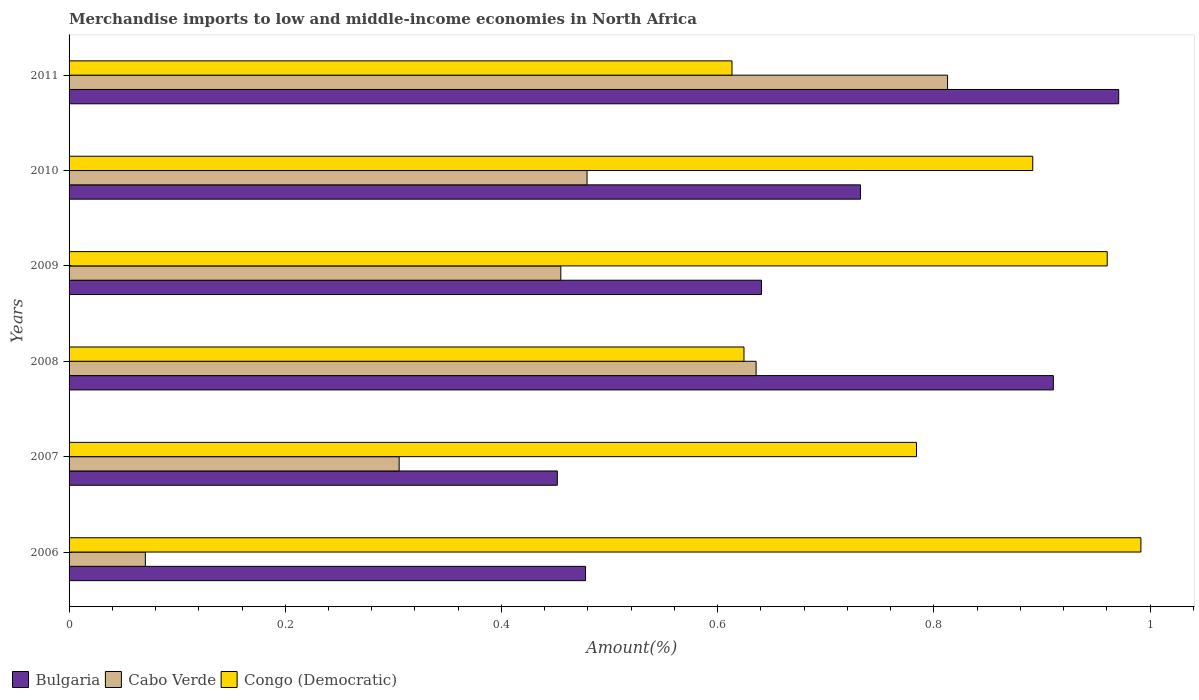How many groups of bars are there?
Provide a short and direct response. 6. How many bars are there on the 5th tick from the top?
Give a very brief answer. 3. How many bars are there on the 3rd tick from the bottom?
Provide a succinct answer. 3. In how many cases, is the number of bars for a given year not equal to the number of legend labels?
Make the answer very short. 0. What is the percentage of amount earned from merchandise imports in Bulgaria in 2008?
Keep it short and to the point. 0.91. Across all years, what is the maximum percentage of amount earned from merchandise imports in Bulgaria?
Provide a succinct answer. 0.97. Across all years, what is the minimum percentage of amount earned from merchandise imports in Bulgaria?
Provide a short and direct response. 0.45. In which year was the percentage of amount earned from merchandise imports in Bulgaria minimum?
Provide a succinct answer. 2007. What is the total percentage of amount earned from merchandise imports in Bulgaria in the graph?
Keep it short and to the point. 4.18. What is the difference between the percentage of amount earned from merchandise imports in Bulgaria in 2009 and that in 2011?
Provide a succinct answer. -0.33. What is the difference between the percentage of amount earned from merchandise imports in Cabo Verde in 2010 and the percentage of amount earned from merchandise imports in Congo (Democratic) in 2006?
Keep it short and to the point. -0.51. What is the average percentage of amount earned from merchandise imports in Congo (Democratic) per year?
Offer a very short reply. 0.81. In the year 2010, what is the difference between the percentage of amount earned from merchandise imports in Bulgaria and percentage of amount earned from merchandise imports in Congo (Democratic)?
Offer a very short reply. -0.16. In how many years, is the percentage of amount earned from merchandise imports in Congo (Democratic) greater than 0.36 %?
Offer a terse response. 6. What is the ratio of the percentage of amount earned from merchandise imports in Cabo Verde in 2006 to that in 2008?
Your answer should be very brief. 0.11. Is the percentage of amount earned from merchandise imports in Bulgaria in 2007 less than that in 2008?
Your response must be concise. Yes. What is the difference between the highest and the second highest percentage of amount earned from merchandise imports in Bulgaria?
Keep it short and to the point. 0.06. What is the difference between the highest and the lowest percentage of amount earned from merchandise imports in Cabo Verde?
Your answer should be compact. 0.74. What does the 1st bar from the top in 2011 represents?
Provide a short and direct response. Congo (Democratic). What does the 3rd bar from the bottom in 2010 represents?
Your answer should be compact. Congo (Democratic). How many bars are there?
Make the answer very short. 18. Does the graph contain any zero values?
Keep it short and to the point. No. Does the graph contain grids?
Your response must be concise. No. Where does the legend appear in the graph?
Your answer should be compact. Bottom left. How are the legend labels stacked?
Your answer should be very brief. Horizontal. What is the title of the graph?
Keep it short and to the point. Merchandise imports to low and middle-income economies in North Africa. Does "Arab World" appear as one of the legend labels in the graph?
Provide a succinct answer. No. What is the label or title of the X-axis?
Provide a succinct answer. Amount(%). What is the label or title of the Y-axis?
Your answer should be very brief. Years. What is the Amount(%) in Bulgaria in 2006?
Your answer should be compact. 0.48. What is the Amount(%) of Cabo Verde in 2006?
Give a very brief answer. 0.07. What is the Amount(%) of Congo (Democratic) in 2006?
Keep it short and to the point. 0.99. What is the Amount(%) in Bulgaria in 2007?
Your response must be concise. 0.45. What is the Amount(%) of Cabo Verde in 2007?
Provide a short and direct response. 0.31. What is the Amount(%) of Congo (Democratic) in 2007?
Your answer should be compact. 0.78. What is the Amount(%) in Bulgaria in 2008?
Ensure brevity in your answer.  0.91. What is the Amount(%) of Cabo Verde in 2008?
Your answer should be compact. 0.64. What is the Amount(%) in Congo (Democratic) in 2008?
Offer a terse response. 0.62. What is the Amount(%) of Bulgaria in 2009?
Provide a short and direct response. 0.64. What is the Amount(%) of Cabo Verde in 2009?
Your answer should be compact. 0.45. What is the Amount(%) of Congo (Democratic) in 2009?
Keep it short and to the point. 0.96. What is the Amount(%) of Bulgaria in 2010?
Keep it short and to the point. 0.73. What is the Amount(%) in Cabo Verde in 2010?
Offer a very short reply. 0.48. What is the Amount(%) of Congo (Democratic) in 2010?
Provide a short and direct response. 0.89. What is the Amount(%) in Bulgaria in 2011?
Provide a succinct answer. 0.97. What is the Amount(%) in Cabo Verde in 2011?
Your response must be concise. 0.81. What is the Amount(%) in Congo (Democratic) in 2011?
Your answer should be very brief. 0.61. Across all years, what is the maximum Amount(%) of Bulgaria?
Provide a short and direct response. 0.97. Across all years, what is the maximum Amount(%) of Cabo Verde?
Provide a succinct answer. 0.81. Across all years, what is the maximum Amount(%) of Congo (Democratic)?
Provide a succinct answer. 0.99. Across all years, what is the minimum Amount(%) in Bulgaria?
Offer a very short reply. 0.45. Across all years, what is the minimum Amount(%) of Cabo Verde?
Ensure brevity in your answer.  0.07. Across all years, what is the minimum Amount(%) in Congo (Democratic)?
Provide a succinct answer. 0.61. What is the total Amount(%) in Bulgaria in the graph?
Provide a short and direct response. 4.18. What is the total Amount(%) in Cabo Verde in the graph?
Your answer should be compact. 2.76. What is the total Amount(%) in Congo (Democratic) in the graph?
Ensure brevity in your answer.  4.87. What is the difference between the Amount(%) in Bulgaria in 2006 and that in 2007?
Your response must be concise. 0.03. What is the difference between the Amount(%) in Cabo Verde in 2006 and that in 2007?
Provide a succinct answer. -0.23. What is the difference between the Amount(%) in Congo (Democratic) in 2006 and that in 2007?
Provide a succinct answer. 0.21. What is the difference between the Amount(%) in Bulgaria in 2006 and that in 2008?
Provide a short and direct response. -0.43. What is the difference between the Amount(%) of Cabo Verde in 2006 and that in 2008?
Provide a short and direct response. -0.56. What is the difference between the Amount(%) in Congo (Democratic) in 2006 and that in 2008?
Ensure brevity in your answer.  0.37. What is the difference between the Amount(%) in Bulgaria in 2006 and that in 2009?
Make the answer very short. -0.16. What is the difference between the Amount(%) in Cabo Verde in 2006 and that in 2009?
Make the answer very short. -0.38. What is the difference between the Amount(%) in Congo (Democratic) in 2006 and that in 2009?
Your answer should be very brief. 0.03. What is the difference between the Amount(%) in Bulgaria in 2006 and that in 2010?
Provide a short and direct response. -0.25. What is the difference between the Amount(%) of Cabo Verde in 2006 and that in 2010?
Your answer should be very brief. -0.41. What is the difference between the Amount(%) of Congo (Democratic) in 2006 and that in 2010?
Offer a very short reply. 0.1. What is the difference between the Amount(%) of Bulgaria in 2006 and that in 2011?
Your answer should be compact. -0.49. What is the difference between the Amount(%) in Cabo Verde in 2006 and that in 2011?
Give a very brief answer. -0.74. What is the difference between the Amount(%) in Congo (Democratic) in 2006 and that in 2011?
Your answer should be compact. 0.38. What is the difference between the Amount(%) in Bulgaria in 2007 and that in 2008?
Offer a terse response. -0.46. What is the difference between the Amount(%) of Cabo Verde in 2007 and that in 2008?
Your answer should be very brief. -0.33. What is the difference between the Amount(%) of Congo (Democratic) in 2007 and that in 2008?
Make the answer very short. 0.16. What is the difference between the Amount(%) in Bulgaria in 2007 and that in 2009?
Your answer should be very brief. -0.19. What is the difference between the Amount(%) in Cabo Verde in 2007 and that in 2009?
Ensure brevity in your answer.  -0.15. What is the difference between the Amount(%) of Congo (Democratic) in 2007 and that in 2009?
Provide a short and direct response. -0.18. What is the difference between the Amount(%) of Bulgaria in 2007 and that in 2010?
Offer a very short reply. -0.28. What is the difference between the Amount(%) in Cabo Verde in 2007 and that in 2010?
Ensure brevity in your answer.  -0.17. What is the difference between the Amount(%) in Congo (Democratic) in 2007 and that in 2010?
Make the answer very short. -0.11. What is the difference between the Amount(%) in Bulgaria in 2007 and that in 2011?
Your answer should be compact. -0.52. What is the difference between the Amount(%) in Cabo Verde in 2007 and that in 2011?
Your answer should be very brief. -0.51. What is the difference between the Amount(%) in Congo (Democratic) in 2007 and that in 2011?
Ensure brevity in your answer.  0.17. What is the difference between the Amount(%) of Bulgaria in 2008 and that in 2009?
Provide a short and direct response. 0.27. What is the difference between the Amount(%) of Cabo Verde in 2008 and that in 2009?
Ensure brevity in your answer.  0.18. What is the difference between the Amount(%) of Congo (Democratic) in 2008 and that in 2009?
Your answer should be very brief. -0.34. What is the difference between the Amount(%) in Bulgaria in 2008 and that in 2010?
Keep it short and to the point. 0.18. What is the difference between the Amount(%) in Cabo Verde in 2008 and that in 2010?
Provide a succinct answer. 0.16. What is the difference between the Amount(%) in Congo (Democratic) in 2008 and that in 2010?
Your response must be concise. -0.27. What is the difference between the Amount(%) of Bulgaria in 2008 and that in 2011?
Make the answer very short. -0.06. What is the difference between the Amount(%) of Cabo Verde in 2008 and that in 2011?
Provide a succinct answer. -0.18. What is the difference between the Amount(%) in Congo (Democratic) in 2008 and that in 2011?
Your response must be concise. 0.01. What is the difference between the Amount(%) of Bulgaria in 2009 and that in 2010?
Your response must be concise. -0.09. What is the difference between the Amount(%) in Cabo Verde in 2009 and that in 2010?
Offer a terse response. -0.02. What is the difference between the Amount(%) in Congo (Democratic) in 2009 and that in 2010?
Make the answer very short. 0.07. What is the difference between the Amount(%) of Bulgaria in 2009 and that in 2011?
Ensure brevity in your answer.  -0.33. What is the difference between the Amount(%) in Cabo Verde in 2009 and that in 2011?
Make the answer very short. -0.36. What is the difference between the Amount(%) of Congo (Democratic) in 2009 and that in 2011?
Keep it short and to the point. 0.35. What is the difference between the Amount(%) of Bulgaria in 2010 and that in 2011?
Give a very brief answer. -0.24. What is the difference between the Amount(%) in Cabo Verde in 2010 and that in 2011?
Make the answer very short. -0.33. What is the difference between the Amount(%) of Congo (Democratic) in 2010 and that in 2011?
Keep it short and to the point. 0.28. What is the difference between the Amount(%) of Bulgaria in 2006 and the Amount(%) of Cabo Verde in 2007?
Make the answer very short. 0.17. What is the difference between the Amount(%) of Bulgaria in 2006 and the Amount(%) of Congo (Democratic) in 2007?
Ensure brevity in your answer.  -0.31. What is the difference between the Amount(%) in Cabo Verde in 2006 and the Amount(%) in Congo (Democratic) in 2007?
Your response must be concise. -0.71. What is the difference between the Amount(%) in Bulgaria in 2006 and the Amount(%) in Cabo Verde in 2008?
Provide a short and direct response. -0.16. What is the difference between the Amount(%) of Bulgaria in 2006 and the Amount(%) of Congo (Democratic) in 2008?
Your answer should be compact. -0.15. What is the difference between the Amount(%) in Cabo Verde in 2006 and the Amount(%) in Congo (Democratic) in 2008?
Provide a short and direct response. -0.55. What is the difference between the Amount(%) in Bulgaria in 2006 and the Amount(%) in Cabo Verde in 2009?
Offer a very short reply. 0.02. What is the difference between the Amount(%) of Bulgaria in 2006 and the Amount(%) of Congo (Democratic) in 2009?
Make the answer very short. -0.48. What is the difference between the Amount(%) of Cabo Verde in 2006 and the Amount(%) of Congo (Democratic) in 2009?
Your response must be concise. -0.89. What is the difference between the Amount(%) in Bulgaria in 2006 and the Amount(%) in Cabo Verde in 2010?
Your answer should be compact. -0. What is the difference between the Amount(%) of Bulgaria in 2006 and the Amount(%) of Congo (Democratic) in 2010?
Offer a terse response. -0.41. What is the difference between the Amount(%) of Cabo Verde in 2006 and the Amount(%) of Congo (Democratic) in 2010?
Your answer should be very brief. -0.82. What is the difference between the Amount(%) in Bulgaria in 2006 and the Amount(%) in Cabo Verde in 2011?
Keep it short and to the point. -0.33. What is the difference between the Amount(%) in Bulgaria in 2006 and the Amount(%) in Congo (Democratic) in 2011?
Keep it short and to the point. -0.14. What is the difference between the Amount(%) in Cabo Verde in 2006 and the Amount(%) in Congo (Democratic) in 2011?
Make the answer very short. -0.54. What is the difference between the Amount(%) in Bulgaria in 2007 and the Amount(%) in Cabo Verde in 2008?
Your answer should be very brief. -0.18. What is the difference between the Amount(%) in Bulgaria in 2007 and the Amount(%) in Congo (Democratic) in 2008?
Make the answer very short. -0.17. What is the difference between the Amount(%) of Cabo Verde in 2007 and the Amount(%) of Congo (Democratic) in 2008?
Your answer should be compact. -0.32. What is the difference between the Amount(%) of Bulgaria in 2007 and the Amount(%) of Cabo Verde in 2009?
Ensure brevity in your answer.  -0. What is the difference between the Amount(%) of Bulgaria in 2007 and the Amount(%) of Congo (Democratic) in 2009?
Your answer should be compact. -0.51. What is the difference between the Amount(%) of Cabo Verde in 2007 and the Amount(%) of Congo (Democratic) in 2009?
Provide a succinct answer. -0.66. What is the difference between the Amount(%) of Bulgaria in 2007 and the Amount(%) of Cabo Verde in 2010?
Keep it short and to the point. -0.03. What is the difference between the Amount(%) of Bulgaria in 2007 and the Amount(%) of Congo (Democratic) in 2010?
Your answer should be compact. -0.44. What is the difference between the Amount(%) of Cabo Verde in 2007 and the Amount(%) of Congo (Democratic) in 2010?
Offer a terse response. -0.59. What is the difference between the Amount(%) of Bulgaria in 2007 and the Amount(%) of Cabo Verde in 2011?
Provide a short and direct response. -0.36. What is the difference between the Amount(%) in Bulgaria in 2007 and the Amount(%) in Congo (Democratic) in 2011?
Your answer should be compact. -0.16. What is the difference between the Amount(%) of Cabo Verde in 2007 and the Amount(%) of Congo (Democratic) in 2011?
Provide a succinct answer. -0.31. What is the difference between the Amount(%) of Bulgaria in 2008 and the Amount(%) of Cabo Verde in 2009?
Offer a terse response. 0.46. What is the difference between the Amount(%) in Bulgaria in 2008 and the Amount(%) in Congo (Democratic) in 2009?
Give a very brief answer. -0.05. What is the difference between the Amount(%) of Cabo Verde in 2008 and the Amount(%) of Congo (Democratic) in 2009?
Your answer should be very brief. -0.32. What is the difference between the Amount(%) of Bulgaria in 2008 and the Amount(%) of Cabo Verde in 2010?
Offer a very short reply. 0.43. What is the difference between the Amount(%) in Bulgaria in 2008 and the Amount(%) in Congo (Democratic) in 2010?
Your answer should be compact. 0.02. What is the difference between the Amount(%) of Cabo Verde in 2008 and the Amount(%) of Congo (Democratic) in 2010?
Make the answer very short. -0.26. What is the difference between the Amount(%) of Bulgaria in 2008 and the Amount(%) of Cabo Verde in 2011?
Your response must be concise. 0.1. What is the difference between the Amount(%) of Bulgaria in 2008 and the Amount(%) of Congo (Democratic) in 2011?
Offer a terse response. 0.3. What is the difference between the Amount(%) in Cabo Verde in 2008 and the Amount(%) in Congo (Democratic) in 2011?
Offer a very short reply. 0.02. What is the difference between the Amount(%) in Bulgaria in 2009 and the Amount(%) in Cabo Verde in 2010?
Offer a terse response. 0.16. What is the difference between the Amount(%) in Bulgaria in 2009 and the Amount(%) in Congo (Democratic) in 2010?
Give a very brief answer. -0.25. What is the difference between the Amount(%) in Cabo Verde in 2009 and the Amount(%) in Congo (Democratic) in 2010?
Offer a very short reply. -0.44. What is the difference between the Amount(%) in Bulgaria in 2009 and the Amount(%) in Cabo Verde in 2011?
Your answer should be compact. -0.17. What is the difference between the Amount(%) in Bulgaria in 2009 and the Amount(%) in Congo (Democratic) in 2011?
Make the answer very short. 0.03. What is the difference between the Amount(%) in Cabo Verde in 2009 and the Amount(%) in Congo (Democratic) in 2011?
Provide a short and direct response. -0.16. What is the difference between the Amount(%) in Bulgaria in 2010 and the Amount(%) in Cabo Verde in 2011?
Keep it short and to the point. -0.08. What is the difference between the Amount(%) in Bulgaria in 2010 and the Amount(%) in Congo (Democratic) in 2011?
Ensure brevity in your answer.  0.12. What is the difference between the Amount(%) of Cabo Verde in 2010 and the Amount(%) of Congo (Democratic) in 2011?
Provide a short and direct response. -0.13. What is the average Amount(%) of Bulgaria per year?
Make the answer very short. 0.7. What is the average Amount(%) of Cabo Verde per year?
Ensure brevity in your answer.  0.46. What is the average Amount(%) of Congo (Democratic) per year?
Offer a terse response. 0.81. In the year 2006, what is the difference between the Amount(%) of Bulgaria and Amount(%) of Cabo Verde?
Offer a very short reply. 0.41. In the year 2006, what is the difference between the Amount(%) in Bulgaria and Amount(%) in Congo (Democratic)?
Your answer should be compact. -0.51. In the year 2006, what is the difference between the Amount(%) of Cabo Verde and Amount(%) of Congo (Democratic)?
Provide a succinct answer. -0.92. In the year 2007, what is the difference between the Amount(%) in Bulgaria and Amount(%) in Cabo Verde?
Provide a succinct answer. 0.15. In the year 2007, what is the difference between the Amount(%) in Bulgaria and Amount(%) in Congo (Democratic)?
Make the answer very short. -0.33. In the year 2007, what is the difference between the Amount(%) in Cabo Verde and Amount(%) in Congo (Democratic)?
Make the answer very short. -0.48. In the year 2008, what is the difference between the Amount(%) in Bulgaria and Amount(%) in Cabo Verde?
Give a very brief answer. 0.28. In the year 2008, what is the difference between the Amount(%) in Bulgaria and Amount(%) in Congo (Democratic)?
Ensure brevity in your answer.  0.29. In the year 2008, what is the difference between the Amount(%) of Cabo Verde and Amount(%) of Congo (Democratic)?
Offer a very short reply. 0.01. In the year 2009, what is the difference between the Amount(%) in Bulgaria and Amount(%) in Cabo Verde?
Your answer should be compact. 0.19. In the year 2009, what is the difference between the Amount(%) in Bulgaria and Amount(%) in Congo (Democratic)?
Offer a terse response. -0.32. In the year 2009, what is the difference between the Amount(%) of Cabo Verde and Amount(%) of Congo (Democratic)?
Offer a very short reply. -0.51. In the year 2010, what is the difference between the Amount(%) of Bulgaria and Amount(%) of Cabo Verde?
Your answer should be compact. 0.25. In the year 2010, what is the difference between the Amount(%) of Bulgaria and Amount(%) of Congo (Democratic)?
Provide a short and direct response. -0.16. In the year 2010, what is the difference between the Amount(%) in Cabo Verde and Amount(%) in Congo (Democratic)?
Keep it short and to the point. -0.41. In the year 2011, what is the difference between the Amount(%) in Bulgaria and Amount(%) in Cabo Verde?
Your answer should be compact. 0.16. In the year 2011, what is the difference between the Amount(%) of Bulgaria and Amount(%) of Congo (Democratic)?
Keep it short and to the point. 0.36. In the year 2011, what is the difference between the Amount(%) in Cabo Verde and Amount(%) in Congo (Democratic)?
Your response must be concise. 0.2. What is the ratio of the Amount(%) in Bulgaria in 2006 to that in 2007?
Provide a succinct answer. 1.06. What is the ratio of the Amount(%) in Cabo Verde in 2006 to that in 2007?
Your answer should be compact. 0.23. What is the ratio of the Amount(%) of Congo (Democratic) in 2006 to that in 2007?
Offer a terse response. 1.26. What is the ratio of the Amount(%) of Bulgaria in 2006 to that in 2008?
Your answer should be very brief. 0.52. What is the ratio of the Amount(%) of Cabo Verde in 2006 to that in 2008?
Provide a short and direct response. 0.11. What is the ratio of the Amount(%) in Congo (Democratic) in 2006 to that in 2008?
Your answer should be compact. 1.59. What is the ratio of the Amount(%) in Bulgaria in 2006 to that in 2009?
Offer a terse response. 0.75. What is the ratio of the Amount(%) of Cabo Verde in 2006 to that in 2009?
Keep it short and to the point. 0.16. What is the ratio of the Amount(%) in Congo (Democratic) in 2006 to that in 2009?
Keep it short and to the point. 1.03. What is the ratio of the Amount(%) of Bulgaria in 2006 to that in 2010?
Offer a very short reply. 0.65. What is the ratio of the Amount(%) of Cabo Verde in 2006 to that in 2010?
Give a very brief answer. 0.15. What is the ratio of the Amount(%) in Congo (Democratic) in 2006 to that in 2010?
Your response must be concise. 1.11. What is the ratio of the Amount(%) of Bulgaria in 2006 to that in 2011?
Your answer should be compact. 0.49. What is the ratio of the Amount(%) of Cabo Verde in 2006 to that in 2011?
Your response must be concise. 0.09. What is the ratio of the Amount(%) of Congo (Democratic) in 2006 to that in 2011?
Give a very brief answer. 1.62. What is the ratio of the Amount(%) in Bulgaria in 2007 to that in 2008?
Make the answer very short. 0.5. What is the ratio of the Amount(%) of Cabo Verde in 2007 to that in 2008?
Keep it short and to the point. 0.48. What is the ratio of the Amount(%) in Congo (Democratic) in 2007 to that in 2008?
Offer a very short reply. 1.26. What is the ratio of the Amount(%) in Bulgaria in 2007 to that in 2009?
Provide a short and direct response. 0.71. What is the ratio of the Amount(%) in Cabo Verde in 2007 to that in 2009?
Your response must be concise. 0.67. What is the ratio of the Amount(%) of Congo (Democratic) in 2007 to that in 2009?
Your answer should be compact. 0.82. What is the ratio of the Amount(%) of Bulgaria in 2007 to that in 2010?
Give a very brief answer. 0.62. What is the ratio of the Amount(%) of Cabo Verde in 2007 to that in 2010?
Your answer should be compact. 0.64. What is the ratio of the Amount(%) in Congo (Democratic) in 2007 to that in 2010?
Provide a short and direct response. 0.88. What is the ratio of the Amount(%) of Bulgaria in 2007 to that in 2011?
Ensure brevity in your answer.  0.47. What is the ratio of the Amount(%) of Cabo Verde in 2007 to that in 2011?
Keep it short and to the point. 0.38. What is the ratio of the Amount(%) of Congo (Democratic) in 2007 to that in 2011?
Provide a succinct answer. 1.28. What is the ratio of the Amount(%) in Bulgaria in 2008 to that in 2009?
Ensure brevity in your answer.  1.42. What is the ratio of the Amount(%) of Cabo Verde in 2008 to that in 2009?
Your response must be concise. 1.4. What is the ratio of the Amount(%) in Congo (Democratic) in 2008 to that in 2009?
Keep it short and to the point. 0.65. What is the ratio of the Amount(%) in Bulgaria in 2008 to that in 2010?
Provide a short and direct response. 1.24. What is the ratio of the Amount(%) in Cabo Verde in 2008 to that in 2010?
Ensure brevity in your answer.  1.33. What is the ratio of the Amount(%) of Congo (Democratic) in 2008 to that in 2010?
Keep it short and to the point. 0.7. What is the ratio of the Amount(%) in Bulgaria in 2008 to that in 2011?
Your answer should be compact. 0.94. What is the ratio of the Amount(%) in Cabo Verde in 2008 to that in 2011?
Your response must be concise. 0.78. What is the ratio of the Amount(%) in Congo (Democratic) in 2008 to that in 2011?
Give a very brief answer. 1.02. What is the ratio of the Amount(%) of Bulgaria in 2009 to that in 2010?
Offer a very short reply. 0.87. What is the ratio of the Amount(%) of Cabo Verde in 2009 to that in 2010?
Make the answer very short. 0.95. What is the ratio of the Amount(%) in Congo (Democratic) in 2009 to that in 2010?
Your answer should be compact. 1.08. What is the ratio of the Amount(%) in Bulgaria in 2009 to that in 2011?
Make the answer very short. 0.66. What is the ratio of the Amount(%) of Cabo Verde in 2009 to that in 2011?
Ensure brevity in your answer.  0.56. What is the ratio of the Amount(%) of Congo (Democratic) in 2009 to that in 2011?
Provide a succinct answer. 1.57. What is the ratio of the Amount(%) of Bulgaria in 2010 to that in 2011?
Offer a very short reply. 0.75. What is the ratio of the Amount(%) of Cabo Verde in 2010 to that in 2011?
Keep it short and to the point. 0.59. What is the ratio of the Amount(%) in Congo (Democratic) in 2010 to that in 2011?
Keep it short and to the point. 1.45. What is the difference between the highest and the second highest Amount(%) in Bulgaria?
Offer a terse response. 0.06. What is the difference between the highest and the second highest Amount(%) in Cabo Verde?
Provide a short and direct response. 0.18. What is the difference between the highest and the second highest Amount(%) in Congo (Democratic)?
Provide a short and direct response. 0.03. What is the difference between the highest and the lowest Amount(%) of Bulgaria?
Keep it short and to the point. 0.52. What is the difference between the highest and the lowest Amount(%) in Cabo Verde?
Offer a very short reply. 0.74. What is the difference between the highest and the lowest Amount(%) of Congo (Democratic)?
Your answer should be compact. 0.38. 